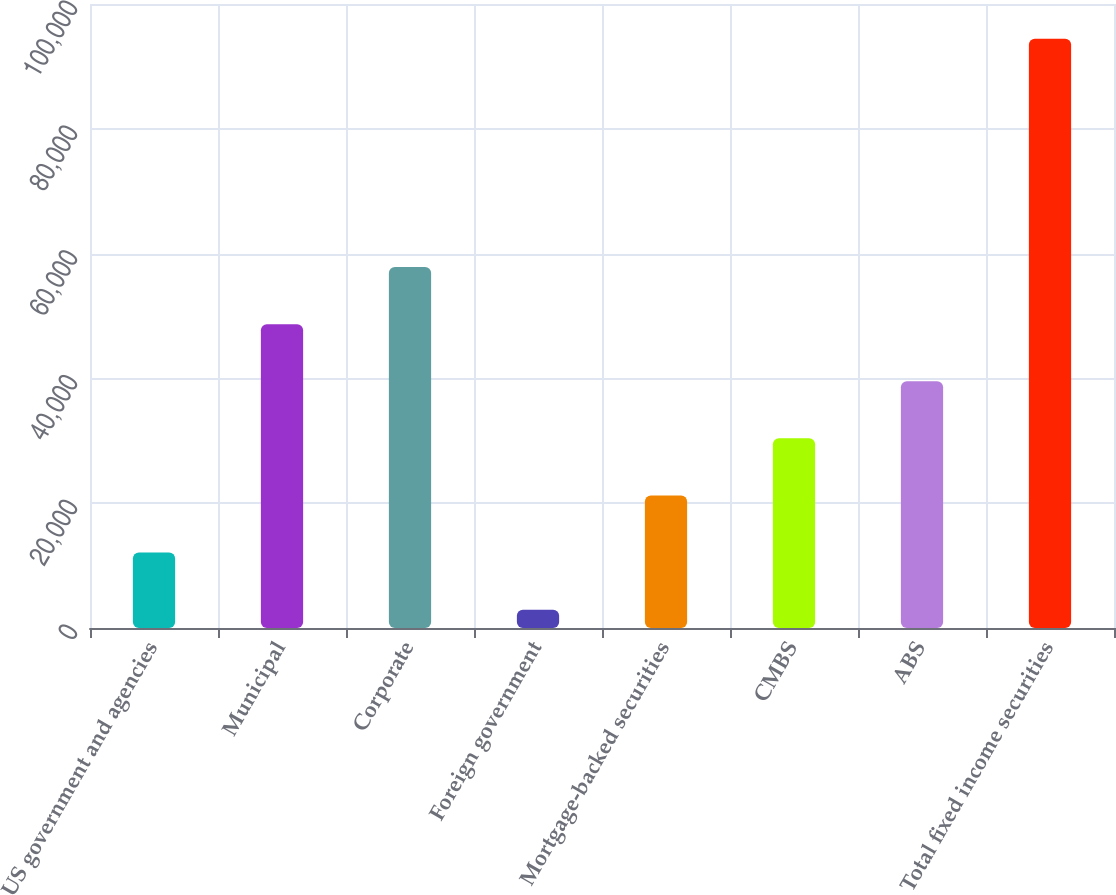<chart> <loc_0><loc_0><loc_500><loc_500><bar_chart><fcel>US government and agencies<fcel>Municipal<fcel>Corporate<fcel>Foreign government<fcel>Mortgage-backed securities<fcel>CMBS<fcel>ABS<fcel>Total fixed income securities<nl><fcel>12087.5<fcel>48693.5<fcel>57845<fcel>2936<fcel>21239<fcel>30390.5<fcel>39542<fcel>94451<nl></chart> 